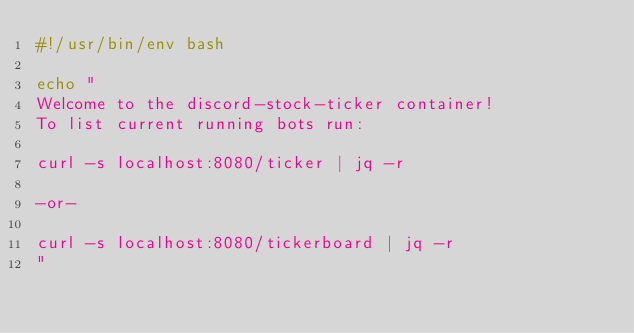Convert code to text. <code><loc_0><loc_0><loc_500><loc_500><_Bash_>#!/usr/bin/env bash

echo "
Welcome to the discord-stock-ticker container!
To list current running bots run:

curl -s localhost:8080/ticker | jq -r

-or-

curl -s localhost:8080/tickerboard | jq -r
"</code> 